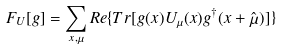<formula> <loc_0><loc_0><loc_500><loc_500>F _ { U } [ g ] = \sum _ { x , \mu } R e \{ T r [ g ( x ) U _ { \mu } ( x ) g ^ { \dagger } ( x + \hat { \mu } ) ] \}</formula> 